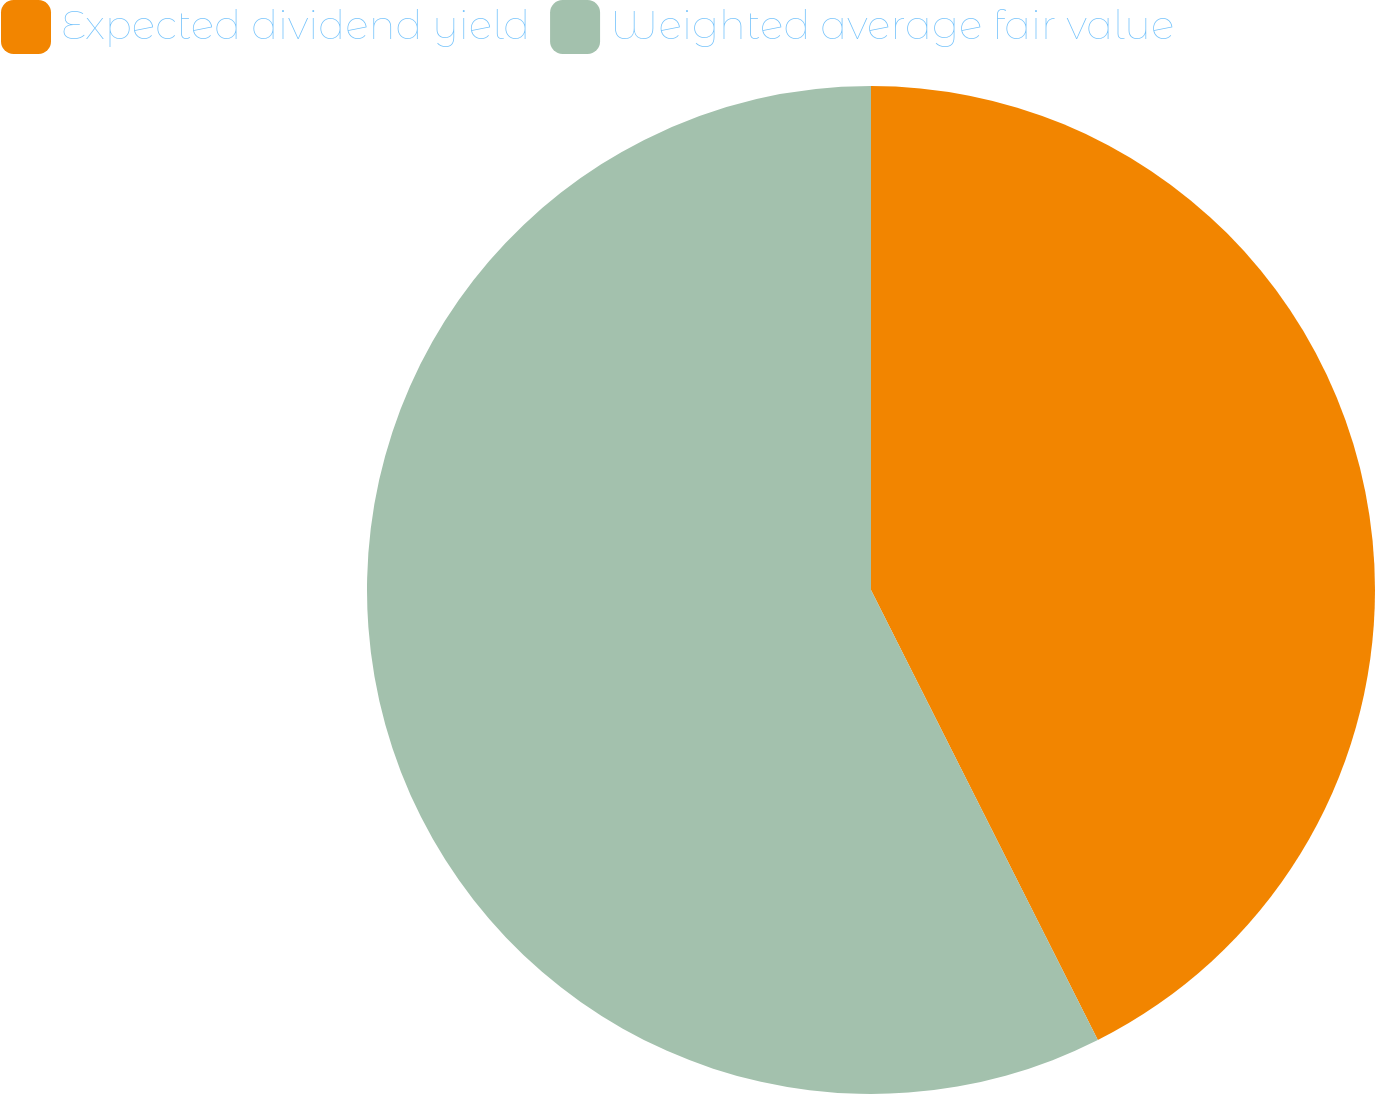<chart> <loc_0><loc_0><loc_500><loc_500><pie_chart><fcel>Expected dividend yield<fcel>Weighted average fair value<nl><fcel>42.57%<fcel>57.43%<nl></chart> 